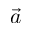Convert formula to latex. <formula><loc_0><loc_0><loc_500><loc_500>\vec { a }</formula> 